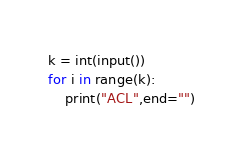Convert code to text. <code><loc_0><loc_0><loc_500><loc_500><_Python_>k = int(input())
for i in range(k):
    print("ACL",end="")</code> 